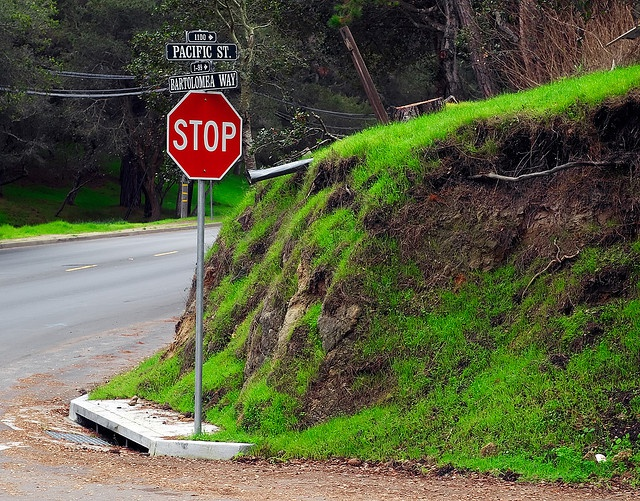Describe the objects in this image and their specific colors. I can see a stop sign in darkgreen, brown, lightgray, and darkgray tones in this image. 